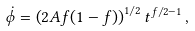Convert formula to latex. <formula><loc_0><loc_0><loc_500><loc_500>\dot { \phi } = \left ( 2 A f ( 1 - f ) \right ) ^ { 1 / 2 } t ^ { f / 2 - 1 } \, ,</formula> 